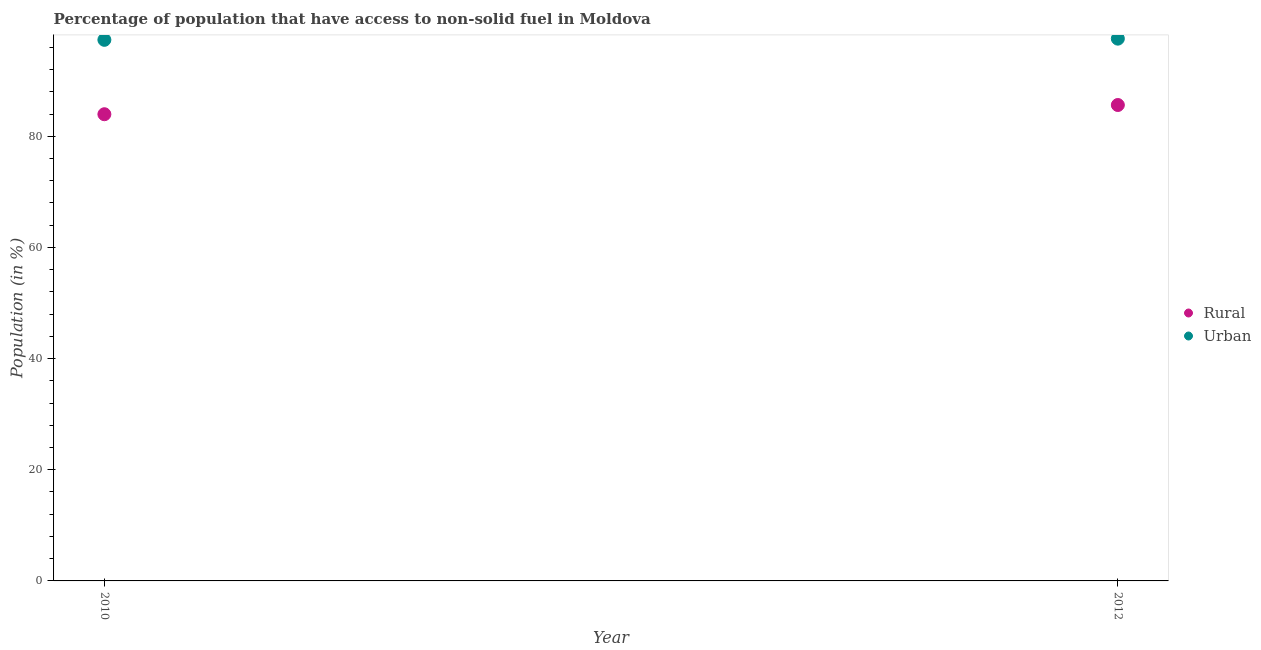How many different coloured dotlines are there?
Give a very brief answer. 2. Is the number of dotlines equal to the number of legend labels?
Offer a very short reply. Yes. What is the urban population in 2010?
Offer a very short reply. 97.35. Across all years, what is the maximum rural population?
Your response must be concise. 85.62. Across all years, what is the minimum rural population?
Your answer should be very brief. 83.96. In which year was the urban population minimum?
Your answer should be very brief. 2010. What is the total rural population in the graph?
Offer a terse response. 169.58. What is the difference between the rural population in 2010 and that in 2012?
Offer a terse response. -1.66. What is the difference between the urban population in 2010 and the rural population in 2012?
Provide a short and direct response. 11.72. What is the average rural population per year?
Offer a terse response. 84.79. In the year 2012, what is the difference between the urban population and rural population?
Your answer should be very brief. 11.94. What is the ratio of the urban population in 2010 to that in 2012?
Ensure brevity in your answer.  1. Is the urban population in 2010 less than that in 2012?
Ensure brevity in your answer.  Yes. In how many years, is the rural population greater than the average rural population taken over all years?
Keep it short and to the point. 1. Is the urban population strictly less than the rural population over the years?
Provide a short and direct response. No. How many dotlines are there?
Your answer should be very brief. 2. How many years are there in the graph?
Your answer should be compact. 2. What is the difference between two consecutive major ticks on the Y-axis?
Your response must be concise. 20. Are the values on the major ticks of Y-axis written in scientific E-notation?
Keep it short and to the point. No. Where does the legend appear in the graph?
Offer a very short reply. Center right. How many legend labels are there?
Keep it short and to the point. 2. What is the title of the graph?
Give a very brief answer. Percentage of population that have access to non-solid fuel in Moldova. What is the label or title of the X-axis?
Keep it short and to the point. Year. What is the Population (in %) in Rural in 2010?
Your response must be concise. 83.96. What is the Population (in %) of Urban in 2010?
Offer a terse response. 97.35. What is the Population (in %) of Rural in 2012?
Offer a very short reply. 85.62. What is the Population (in %) in Urban in 2012?
Offer a very short reply. 97.56. Across all years, what is the maximum Population (in %) in Rural?
Give a very brief answer. 85.62. Across all years, what is the maximum Population (in %) of Urban?
Offer a very short reply. 97.56. Across all years, what is the minimum Population (in %) of Rural?
Offer a very short reply. 83.96. Across all years, what is the minimum Population (in %) in Urban?
Make the answer very short. 97.35. What is the total Population (in %) in Rural in the graph?
Your answer should be very brief. 169.58. What is the total Population (in %) in Urban in the graph?
Offer a very short reply. 194.9. What is the difference between the Population (in %) in Rural in 2010 and that in 2012?
Provide a succinct answer. -1.66. What is the difference between the Population (in %) of Urban in 2010 and that in 2012?
Make the answer very short. -0.21. What is the difference between the Population (in %) in Rural in 2010 and the Population (in %) in Urban in 2012?
Offer a terse response. -13.6. What is the average Population (in %) of Rural per year?
Make the answer very short. 84.79. What is the average Population (in %) in Urban per year?
Your answer should be compact. 97.45. In the year 2010, what is the difference between the Population (in %) in Rural and Population (in %) in Urban?
Keep it short and to the point. -13.38. In the year 2012, what is the difference between the Population (in %) of Rural and Population (in %) of Urban?
Offer a terse response. -11.94. What is the ratio of the Population (in %) of Rural in 2010 to that in 2012?
Make the answer very short. 0.98. What is the difference between the highest and the second highest Population (in %) of Rural?
Offer a very short reply. 1.66. What is the difference between the highest and the second highest Population (in %) of Urban?
Give a very brief answer. 0.21. What is the difference between the highest and the lowest Population (in %) in Rural?
Ensure brevity in your answer.  1.66. What is the difference between the highest and the lowest Population (in %) in Urban?
Ensure brevity in your answer.  0.21. 